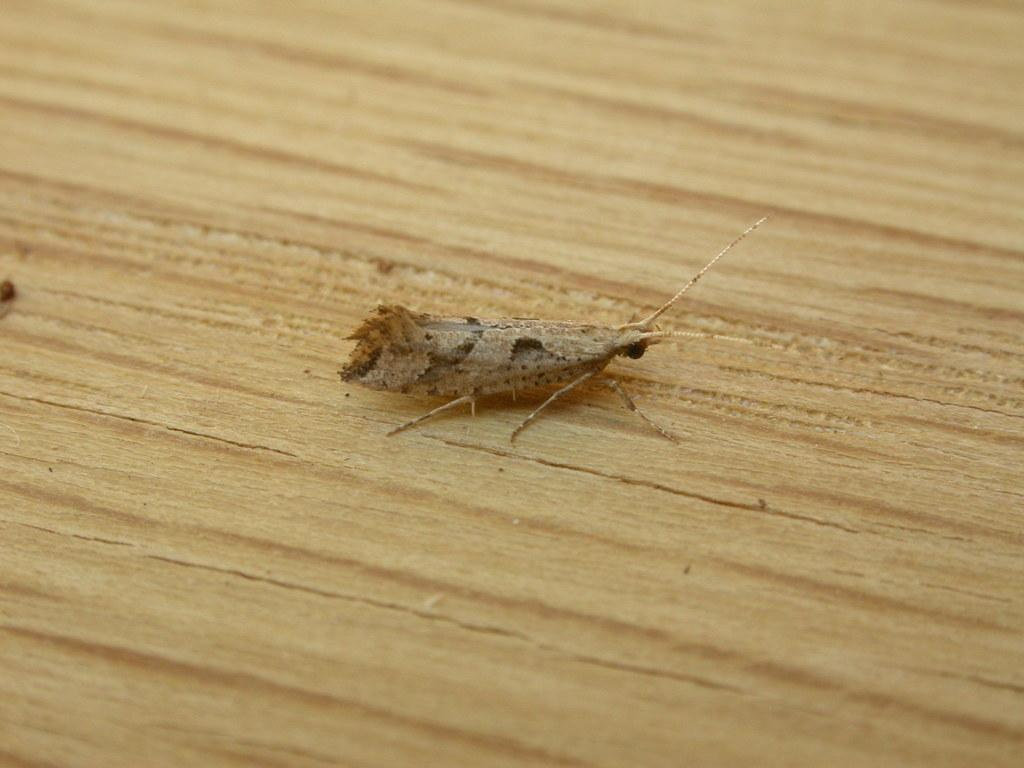What type of insect is in the image? There is a brown house moth in the image. What surface is the house moth on? The house moth is on a wooden floor. What type of carriage is being pulled by the house moth in the image? There is no carriage present in the image, as it features a brown house moth on a wooden floor. 